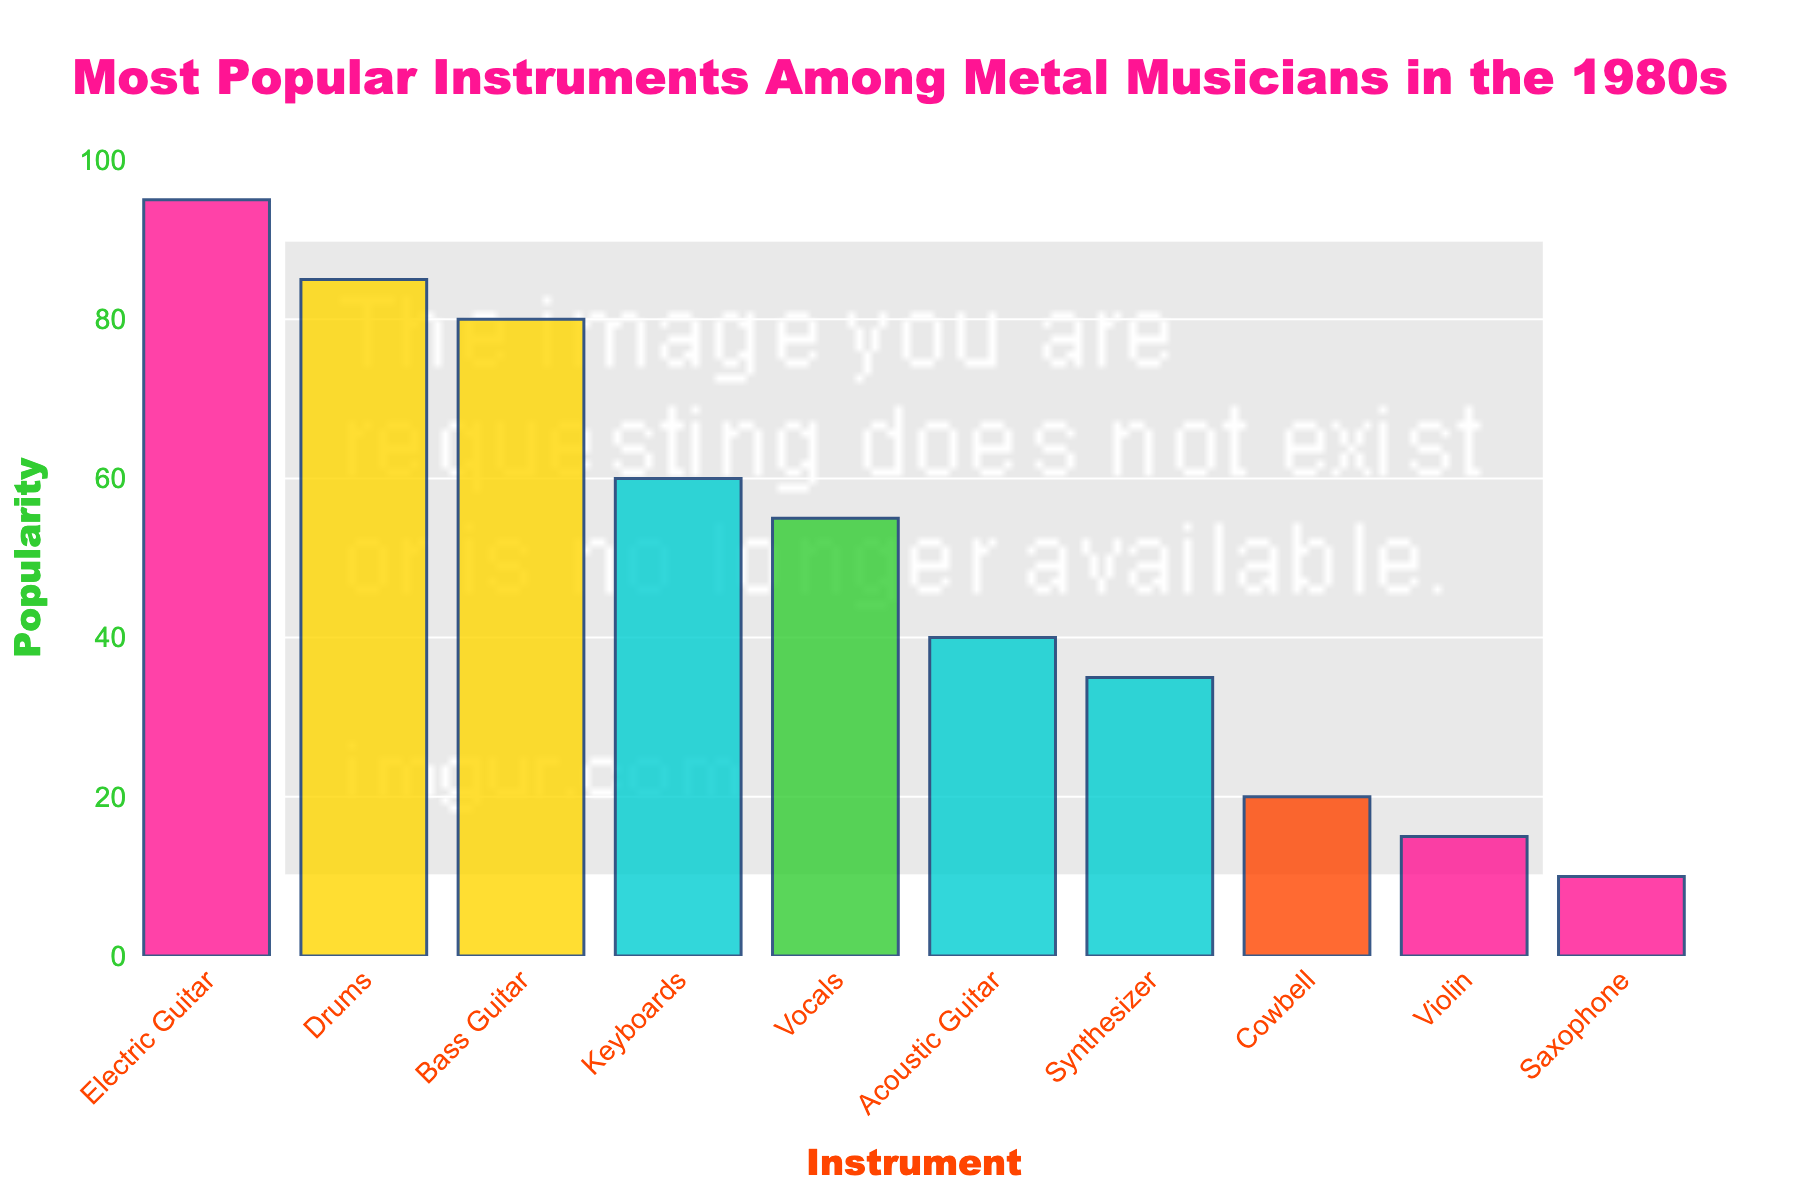What is the most popular instrument among metal musicians in the 1980s? The highest bar in the chart represents the Electric Guitar, indicating it has the highest popularity.
Answer: Electric Guitar Which instrument is more popular, Bass Guitar or Keyboards? The bar for Bass Guitar is taller than the bar for Keyboards, indicating it has a higher popularity score.
Answer: Bass Guitar What is the total popularity of Vocals and Drums combined? By looking at the chart, Vocals have a popularity of 55, and Drums have a popularity of 85. Adding them together: 55 + 85 = 140
Answer: 140 How much more popular is the Electric Guitar compared to the Acoustic Guitar? The chart shows the popularity of Electric Guitar is 95 and Acoustic Guitar is 40. Subtract the popularity of Acoustic Guitar from Electric Guitar: 95 - 40 = 55
Answer: 55 Which instrument has the lowest popularity and what is its score? The shortest bar in the chart represents the Saxophone, indicating it has the lowest popularity score of 10.
Answer: Saxophone, 10 What is the average popularity of the top three instruments? The top three instruments by popularity are Electric Guitar (95), Drums (85), and Bass Guitar (80). Adding their popularity scores: 95 + 85 + 80 = 260. Dividing by 3: 260 / 3 = 86.67
Answer: 86.67 Which instrument has a popularity of 20? The bar with the popularity score of 20 corresponds to the Cowbell.
Answer: Cowbell Is the popularity of Synthesizer greater than or equal to the popularity of Acoustic Guitar? Synthesizer has a popularity of 35 and Acoustic Guitar has a popularity of 40. Since 35 is less than 40, the answer is no.
Answer: No How many instruments have a popularity score above 50? The instruments with popularity scores above 50 are Electric Guitar, Drums, Bass Guitar, Keyboards, and Vocals. Counting them gives a total of 5 instruments.
Answer: 5 What is the combined popularity of the instruments played with strings (Electric Guitar, Bass Guitar, Acoustic Guitar, Violin)? Adding the popularity scores of Electric Guitar (95), Bass Guitar (80), Acoustic Guitar (40), and Violin (15): 95 + 80 + 40 + 15 = 230
Answer: 230 